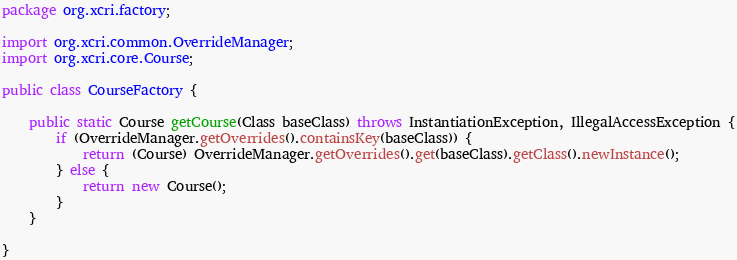Convert code to text. <code><loc_0><loc_0><loc_500><loc_500><_Java_>package org.xcri.factory;

import org.xcri.common.OverrideManager;
import org.xcri.core.Course;

public class CourseFactory {
	
	public static Course getCourse(Class baseClass) throws InstantiationException, IllegalAccessException {
		if (OverrideManager.getOverrides().containsKey(baseClass)) {
			return (Course) OverrideManager.getOverrides().get(baseClass).getClass().newInstance();
		} else {
			return new Course();
		}
	}

}
</code> 